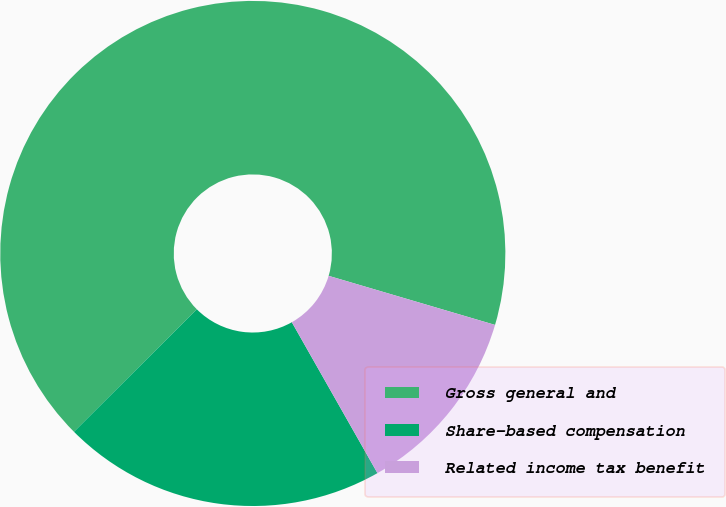Convert chart to OTSL. <chart><loc_0><loc_0><loc_500><loc_500><pie_chart><fcel>Gross general and<fcel>Share-based compensation<fcel>Related income tax benefit<nl><fcel>67.04%<fcel>20.74%<fcel>12.22%<nl></chart> 